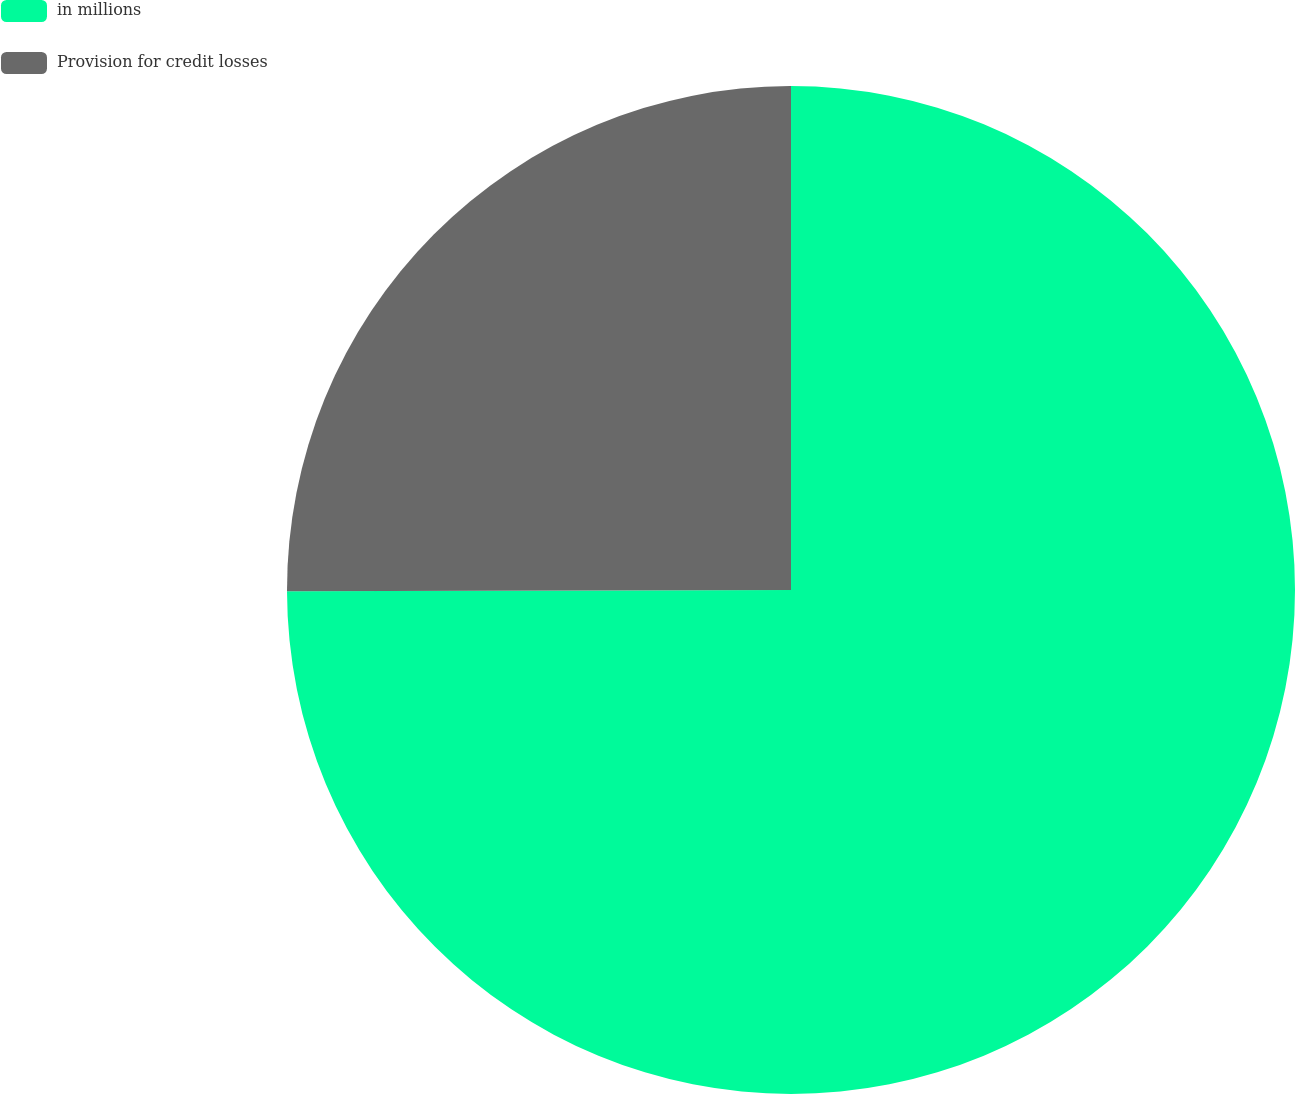Convert chart. <chart><loc_0><loc_0><loc_500><loc_500><pie_chart><fcel>in millions<fcel>Provision for credit losses<nl><fcel>74.96%<fcel>25.04%<nl></chart> 